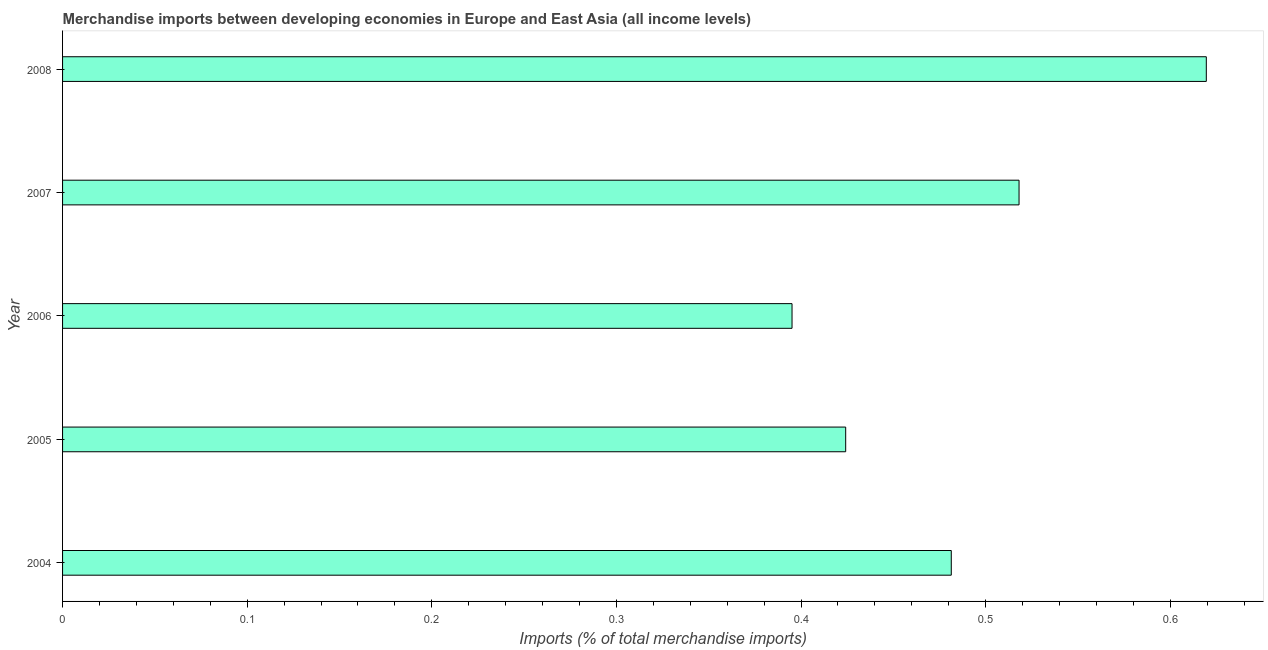Does the graph contain any zero values?
Provide a succinct answer. No. What is the title of the graph?
Your response must be concise. Merchandise imports between developing economies in Europe and East Asia (all income levels). What is the label or title of the X-axis?
Ensure brevity in your answer.  Imports (% of total merchandise imports). What is the label or title of the Y-axis?
Your answer should be compact. Year. What is the merchandise imports in 2004?
Your answer should be very brief. 0.48. Across all years, what is the maximum merchandise imports?
Your answer should be very brief. 0.62. Across all years, what is the minimum merchandise imports?
Offer a very short reply. 0.4. In which year was the merchandise imports minimum?
Make the answer very short. 2006. What is the sum of the merchandise imports?
Your answer should be compact. 2.44. What is the difference between the merchandise imports in 2004 and 2005?
Provide a short and direct response. 0.06. What is the average merchandise imports per year?
Provide a short and direct response. 0.49. What is the median merchandise imports?
Provide a succinct answer. 0.48. What is the ratio of the merchandise imports in 2006 to that in 2007?
Your answer should be compact. 0.76. Is the merchandise imports in 2005 less than that in 2007?
Provide a short and direct response. Yes. What is the difference between the highest and the second highest merchandise imports?
Make the answer very short. 0.1. Is the sum of the merchandise imports in 2004 and 2006 greater than the maximum merchandise imports across all years?
Give a very brief answer. Yes. What is the difference between the highest and the lowest merchandise imports?
Your answer should be compact. 0.22. Are the values on the major ticks of X-axis written in scientific E-notation?
Give a very brief answer. No. What is the Imports (% of total merchandise imports) of 2004?
Provide a succinct answer. 0.48. What is the Imports (% of total merchandise imports) of 2005?
Give a very brief answer. 0.42. What is the Imports (% of total merchandise imports) in 2006?
Your answer should be very brief. 0.4. What is the Imports (% of total merchandise imports) in 2007?
Keep it short and to the point. 0.52. What is the Imports (% of total merchandise imports) of 2008?
Your response must be concise. 0.62. What is the difference between the Imports (% of total merchandise imports) in 2004 and 2005?
Give a very brief answer. 0.06. What is the difference between the Imports (% of total merchandise imports) in 2004 and 2006?
Your answer should be compact. 0.09. What is the difference between the Imports (% of total merchandise imports) in 2004 and 2007?
Ensure brevity in your answer.  -0.04. What is the difference between the Imports (% of total merchandise imports) in 2004 and 2008?
Make the answer very short. -0.14. What is the difference between the Imports (% of total merchandise imports) in 2005 and 2006?
Make the answer very short. 0.03. What is the difference between the Imports (% of total merchandise imports) in 2005 and 2007?
Make the answer very short. -0.09. What is the difference between the Imports (% of total merchandise imports) in 2005 and 2008?
Provide a short and direct response. -0.2. What is the difference between the Imports (% of total merchandise imports) in 2006 and 2007?
Provide a short and direct response. -0.12. What is the difference between the Imports (% of total merchandise imports) in 2006 and 2008?
Give a very brief answer. -0.22. What is the difference between the Imports (% of total merchandise imports) in 2007 and 2008?
Make the answer very short. -0.1. What is the ratio of the Imports (% of total merchandise imports) in 2004 to that in 2005?
Your answer should be compact. 1.14. What is the ratio of the Imports (% of total merchandise imports) in 2004 to that in 2006?
Ensure brevity in your answer.  1.22. What is the ratio of the Imports (% of total merchandise imports) in 2004 to that in 2007?
Provide a succinct answer. 0.93. What is the ratio of the Imports (% of total merchandise imports) in 2004 to that in 2008?
Your answer should be very brief. 0.78. What is the ratio of the Imports (% of total merchandise imports) in 2005 to that in 2006?
Provide a short and direct response. 1.07. What is the ratio of the Imports (% of total merchandise imports) in 2005 to that in 2007?
Provide a succinct answer. 0.82. What is the ratio of the Imports (% of total merchandise imports) in 2005 to that in 2008?
Provide a short and direct response. 0.69. What is the ratio of the Imports (% of total merchandise imports) in 2006 to that in 2007?
Provide a short and direct response. 0.76. What is the ratio of the Imports (% of total merchandise imports) in 2006 to that in 2008?
Provide a short and direct response. 0.64. What is the ratio of the Imports (% of total merchandise imports) in 2007 to that in 2008?
Keep it short and to the point. 0.84. 